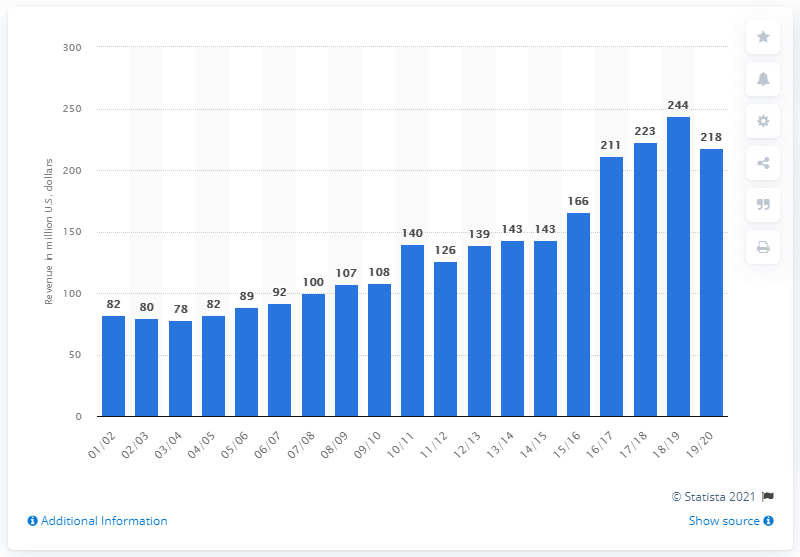Indicate a few pertinent items in this graphic. The estimated revenue of the National Basketball Association franchise for the 2019/2020 season was 21.8 billion U.S. dollars. 